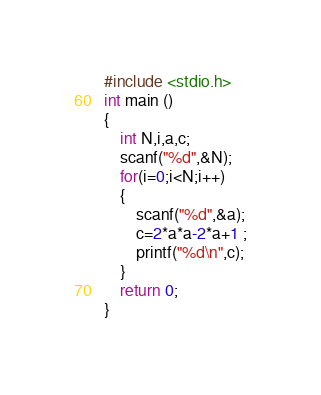Convert code to text. <code><loc_0><loc_0><loc_500><loc_500><_C_>#include <stdio.h>
int main ()
{
	int N,i,a,c;
	scanf("%d",&N);
	for(i=0;i<N;i++)
	{
		scanf("%d",&a);
		c=2*a*a-2*a+1 ;
		printf("%d\n",c);
	}
	return 0; 
}
</code> 